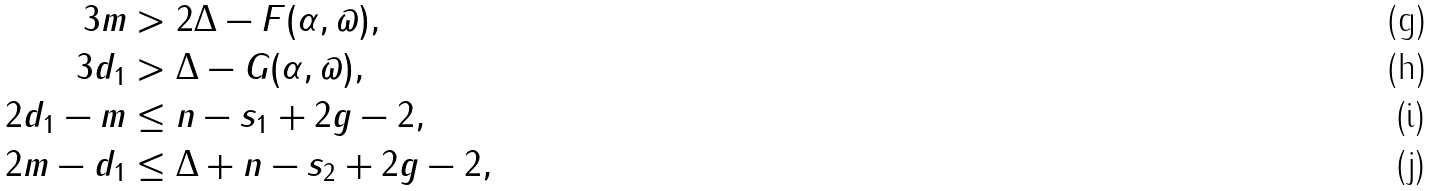Convert formula to latex. <formula><loc_0><loc_0><loc_500><loc_500>3 m & > 2 \Delta - F ( \alpha , \varpi ) , \\ 3 d _ { 1 } & > \Delta - G ( \alpha , \varpi ) , \\ 2 d _ { 1 } - m & \leq n - s _ { 1 } + 2 g - 2 , \\ 2 m - d _ { 1 } & \leq \Delta + n - s _ { 2 } + 2 g - 2 ,</formula> 